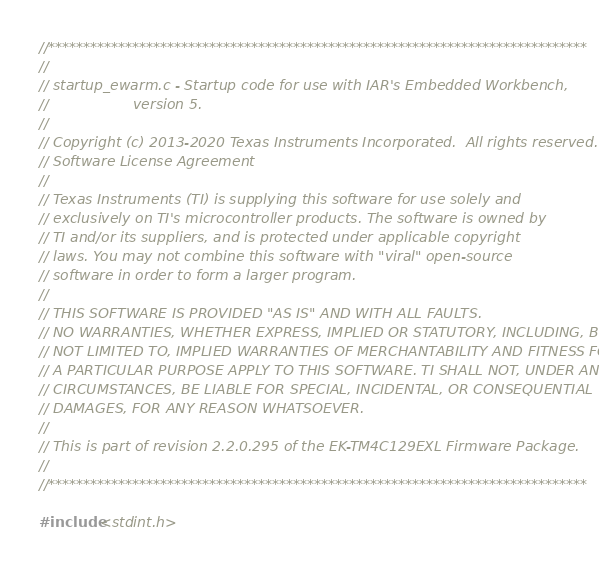<code> <loc_0><loc_0><loc_500><loc_500><_C_>//*****************************************************************************
//
// startup_ewarm.c - Startup code for use with IAR's Embedded Workbench,
//                   version 5.
//
// Copyright (c) 2013-2020 Texas Instruments Incorporated.  All rights reserved.
// Software License Agreement
// 
// Texas Instruments (TI) is supplying this software for use solely and
// exclusively on TI's microcontroller products. The software is owned by
// TI and/or its suppliers, and is protected under applicable copyright
// laws. You may not combine this software with "viral" open-source
// software in order to form a larger program.
// 
// THIS SOFTWARE IS PROVIDED "AS IS" AND WITH ALL FAULTS.
// NO WARRANTIES, WHETHER EXPRESS, IMPLIED OR STATUTORY, INCLUDING, BUT
// NOT LIMITED TO, IMPLIED WARRANTIES OF MERCHANTABILITY AND FITNESS FOR
// A PARTICULAR PURPOSE APPLY TO THIS SOFTWARE. TI SHALL NOT, UNDER ANY
// CIRCUMSTANCES, BE LIABLE FOR SPECIAL, INCIDENTAL, OR CONSEQUENTIAL
// DAMAGES, FOR ANY REASON WHATSOEVER.
// 
// This is part of revision 2.2.0.295 of the EK-TM4C129EXL Firmware Package.
//
//*****************************************************************************

#include <stdint.h></code> 